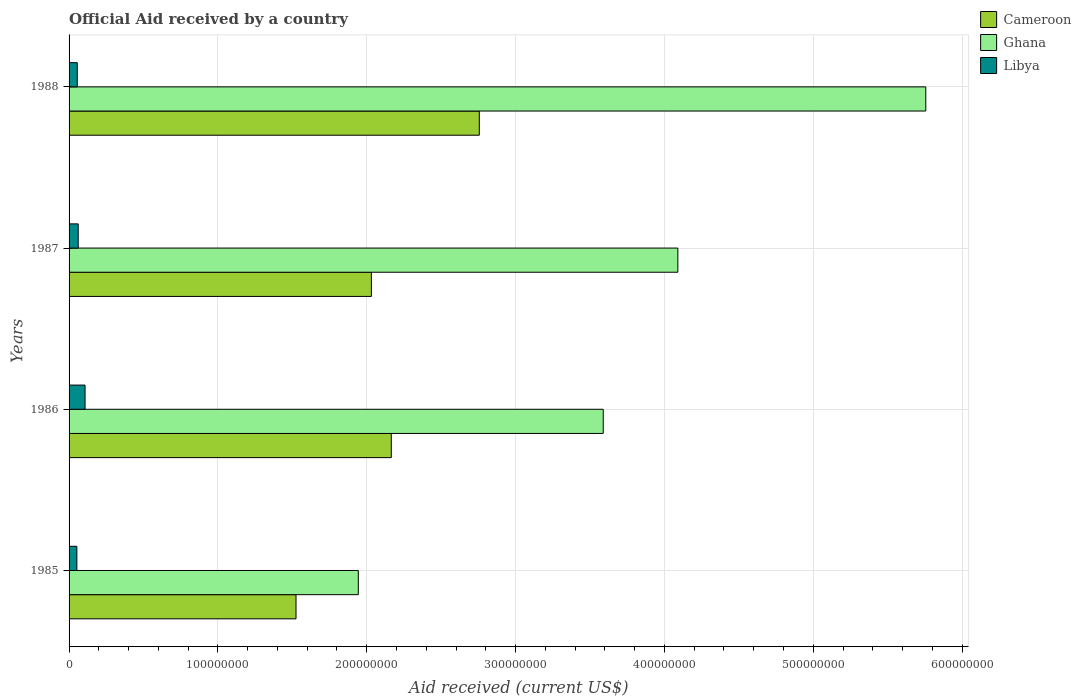Are the number of bars per tick equal to the number of legend labels?
Your response must be concise. Yes. How many bars are there on the 4th tick from the top?
Keep it short and to the point. 3. How many bars are there on the 4th tick from the bottom?
Offer a terse response. 3. What is the label of the 1st group of bars from the top?
Your answer should be very brief. 1988. In how many cases, is the number of bars for a given year not equal to the number of legend labels?
Make the answer very short. 0. What is the net official aid received in Ghana in 1987?
Your response must be concise. 4.09e+08. Across all years, what is the maximum net official aid received in Libya?
Offer a terse response. 1.07e+07. Across all years, what is the minimum net official aid received in Ghana?
Make the answer very short. 1.94e+08. In which year was the net official aid received in Cameroon minimum?
Provide a short and direct response. 1985. What is the total net official aid received in Cameroon in the graph?
Provide a short and direct response. 8.48e+08. What is the difference between the net official aid received in Cameroon in 1985 and that in 1986?
Your answer should be compact. -6.40e+07. What is the difference between the net official aid received in Cameroon in 1985 and the net official aid received in Libya in 1986?
Make the answer very short. 1.42e+08. What is the average net official aid received in Libya per year?
Make the answer very short. 6.90e+06. In the year 1985, what is the difference between the net official aid received in Cameroon and net official aid received in Libya?
Your answer should be compact. 1.47e+08. What is the ratio of the net official aid received in Cameroon in 1985 to that in 1986?
Your answer should be compact. 0.7. Is the net official aid received in Ghana in 1985 less than that in 1986?
Your response must be concise. Yes. What is the difference between the highest and the second highest net official aid received in Libya?
Your answer should be very brief. 4.61e+06. What is the difference between the highest and the lowest net official aid received in Libya?
Ensure brevity in your answer.  5.51e+06. In how many years, is the net official aid received in Cameroon greater than the average net official aid received in Cameroon taken over all years?
Provide a succinct answer. 2. Is the sum of the net official aid received in Cameroon in 1986 and 1988 greater than the maximum net official aid received in Ghana across all years?
Make the answer very short. No. What does the 1st bar from the top in 1987 represents?
Offer a very short reply. Libya. What does the 2nd bar from the bottom in 1987 represents?
Keep it short and to the point. Ghana. How many bars are there?
Give a very brief answer. 12. Are all the bars in the graph horizontal?
Make the answer very short. Yes. What is the difference between two consecutive major ticks on the X-axis?
Provide a short and direct response. 1.00e+08. Are the values on the major ticks of X-axis written in scientific E-notation?
Your response must be concise. No. Does the graph contain any zero values?
Offer a terse response. No. How many legend labels are there?
Keep it short and to the point. 3. What is the title of the graph?
Offer a terse response. Official Aid received by a country. What is the label or title of the X-axis?
Ensure brevity in your answer.  Aid received (current US$). What is the Aid received (current US$) in Cameroon in 1985?
Make the answer very short. 1.52e+08. What is the Aid received (current US$) of Ghana in 1985?
Make the answer very short. 1.94e+08. What is the Aid received (current US$) of Libya in 1985?
Provide a succinct answer. 5.23e+06. What is the Aid received (current US$) in Cameroon in 1986?
Make the answer very short. 2.16e+08. What is the Aid received (current US$) of Ghana in 1986?
Give a very brief answer. 3.59e+08. What is the Aid received (current US$) of Libya in 1986?
Your answer should be very brief. 1.07e+07. What is the Aid received (current US$) of Cameroon in 1987?
Provide a succinct answer. 2.03e+08. What is the Aid received (current US$) of Ghana in 1987?
Your answer should be very brief. 4.09e+08. What is the Aid received (current US$) of Libya in 1987?
Your answer should be compact. 6.13e+06. What is the Aid received (current US$) in Cameroon in 1988?
Provide a short and direct response. 2.76e+08. What is the Aid received (current US$) of Ghana in 1988?
Your answer should be compact. 5.76e+08. What is the Aid received (current US$) in Libya in 1988?
Your answer should be very brief. 5.50e+06. Across all years, what is the maximum Aid received (current US$) in Cameroon?
Your answer should be compact. 2.76e+08. Across all years, what is the maximum Aid received (current US$) in Ghana?
Your answer should be very brief. 5.76e+08. Across all years, what is the maximum Aid received (current US$) in Libya?
Give a very brief answer. 1.07e+07. Across all years, what is the minimum Aid received (current US$) in Cameroon?
Keep it short and to the point. 1.52e+08. Across all years, what is the minimum Aid received (current US$) of Ghana?
Give a very brief answer. 1.94e+08. Across all years, what is the minimum Aid received (current US$) in Libya?
Offer a very short reply. 5.23e+06. What is the total Aid received (current US$) of Cameroon in the graph?
Your response must be concise. 8.48e+08. What is the total Aid received (current US$) of Ghana in the graph?
Keep it short and to the point. 1.54e+09. What is the total Aid received (current US$) of Libya in the graph?
Provide a succinct answer. 2.76e+07. What is the difference between the Aid received (current US$) in Cameroon in 1985 and that in 1986?
Make the answer very short. -6.40e+07. What is the difference between the Aid received (current US$) of Ghana in 1985 and that in 1986?
Keep it short and to the point. -1.65e+08. What is the difference between the Aid received (current US$) of Libya in 1985 and that in 1986?
Offer a very short reply. -5.51e+06. What is the difference between the Aid received (current US$) in Cameroon in 1985 and that in 1987?
Your answer should be very brief. -5.06e+07. What is the difference between the Aid received (current US$) of Ghana in 1985 and that in 1987?
Offer a very short reply. -2.15e+08. What is the difference between the Aid received (current US$) in Libya in 1985 and that in 1987?
Make the answer very short. -9.00e+05. What is the difference between the Aid received (current US$) of Cameroon in 1985 and that in 1988?
Give a very brief answer. -1.23e+08. What is the difference between the Aid received (current US$) in Ghana in 1985 and that in 1988?
Offer a terse response. -3.81e+08. What is the difference between the Aid received (current US$) of Cameroon in 1986 and that in 1987?
Offer a terse response. 1.34e+07. What is the difference between the Aid received (current US$) in Ghana in 1986 and that in 1987?
Your response must be concise. -5.01e+07. What is the difference between the Aid received (current US$) in Libya in 1986 and that in 1987?
Your answer should be very brief. 4.61e+06. What is the difference between the Aid received (current US$) in Cameroon in 1986 and that in 1988?
Your answer should be compact. -5.91e+07. What is the difference between the Aid received (current US$) in Ghana in 1986 and that in 1988?
Offer a terse response. -2.17e+08. What is the difference between the Aid received (current US$) of Libya in 1986 and that in 1988?
Your answer should be compact. 5.24e+06. What is the difference between the Aid received (current US$) in Cameroon in 1987 and that in 1988?
Your response must be concise. -7.25e+07. What is the difference between the Aid received (current US$) in Ghana in 1987 and that in 1988?
Keep it short and to the point. -1.67e+08. What is the difference between the Aid received (current US$) of Libya in 1987 and that in 1988?
Offer a terse response. 6.30e+05. What is the difference between the Aid received (current US$) of Cameroon in 1985 and the Aid received (current US$) of Ghana in 1986?
Offer a terse response. -2.06e+08. What is the difference between the Aid received (current US$) in Cameroon in 1985 and the Aid received (current US$) in Libya in 1986?
Offer a terse response. 1.42e+08. What is the difference between the Aid received (current US$) of Ghana in 1985 and the Aid received (current US$) of Libya in 1986?
Provide a short and direct response. 1.84e+08. What is the difference between the Aid received (current US$) of Cameroon in 1985 and the Aid received (current US$) of Ghana in 1987?
Your response must be concise. -2.57e+08. What is the difference between the Aid received (current US$) in Cameroon in 1985 and the Aid received (current US$) in Libya in 1987?
Offer a terse response. 1.46e+08. What is the difference between the Aid received (current US$) in Ghana in 1985 and the Aid received (current US$) in Libya in 1987?
Your answer should be very brief. 1.88e+08. What is the difference between the Aid received (current US$) in Cameroon in 1985 and the Aid received (current US$) in Ghana in 1988?
Offer a very short reply. -4.23e+08. What is the difference between the Aid received (current US$) of Cameroon in 1985 and the Aid received (current US$) of Libya in 1988?
Offer a very short reply. 1.47e+08. What is the difference between the Aid received (current US$) in Ghana in 1985 and the Aid received (current US$) in Libya in 1988?
Ensure brevity in your answer.  1.89e+08. What is the difference between the Aid received (current US$) in Cameroon in 1986 and the Aid received (current US$) in Ghana in 1987?
Your answer should be very brief. -1.93e+08. What is the difference between the Aid received (current US$) in Cameroon in 1986 and the Aid received (current US$) in Libya in 1987?
Offer a terse response. 2.10e+08. What is the difference between the Aid received (current US$) of Ghana in 1986 and the Aid received (current US$) of Libya in 1987?
Make the answer very short. 3.53e+08. What is the difference between the Aid received (current US$) in Cameroon in 1986 and the Aid received (current US$) in Ghana in 1988?
Provide a short and direct response. -3.59e+08. What is the difference between the Aid received (current US$) of Cameroon in 1986 and the Aid received (current US$) of Libya in 1988?
Your response must be concise. 2.11e+08. What is the difference between the Aid received (current US$) of Ghana in 1986 and the Aid received (current US$) of Libya in 1988?
Your response must be concise. 3.53e+08. What is the difference between the Aid received (current US$) of Cameroon in 1987 and the Aid received (current US$) of Ghana in 1988?
Offer a terse response. -3.72e+08. What is the difference between the Aid received (current US$) of Cameroon in 1987 and the Aid received (current US$) of Libya in 1988?
Your answer should be very brief. 1.98e+08. What is the difference between the Aid received (current US$) of Ghana in 1987 and the Aid received (current US$) of Libya in 1988?
Keep it short and to the point. 4.04e+08. What is the average Aid received (current US$) of Cameroon per year?
Ensure brevity in your answer.  2.12e+08. What is the average Aid received (current US$) in Ghana per year?
Your response must be concise. 3.84e+08. What is the average Aid received (current US$) in Libya per year?
Provide a short and direct response. 6.90e+06. In the year 1985, what is the difference between the Aid received (current US$) in Cameroon and Aid received (current US$) in Ghana?
Offer a very short reply. -4.18e+07. In the year 1985, what is the difference between the Aid received (current US$) in Cameroon and Aid received (current US$) in Libya?
Your response must be concise. 1.47e+08. In the year 1985, what is the difference between the Aid received (current US$) in Ghana and Aid received (current US$) in Libya?
Offer a terse response. 1.89e+08. In the year 1986, what is the difference between the Aid received (current US$) in Cameroon and Aid received (current US$) in Ghana?
Offer a very short reply. -1.42e+08. In the year 1986, what is the difference between the Aid received (current US$) in Cameroon and Aid received (current US$) in Libya?
Your answer should be very brief. 2.06e+08. In the year 1986, what is the difference between the Aid received (current US$) in Ghana and Aid received (current US$) in Libya?
Provide a succinct answer. 3.48e+08. In the year 1987, what is the difference between the Aid received (current US$) of Cameroon and Aid received (current US$) of Ghana?
Offer a terse response. -2.06e+08. In the year 1987, what is the difference between the Aid received (current US$) in Cameroon and Aid received (current US$) in Libya?
Ensure brevity in your answer.  1.97e+08. In the year 1987, what is the difference between the Aid received (current US$) of Ghana and Aid received (current US$) of Libya?
Offer a very short reply. 4.03e+08. In the year 1988, what is the difference between the Aid received (current US$) of Cameroon and Aid received (current US$) of Ghana?
Provide a short and direct response. -3.00e+08. In the year 1988, what is the difference between the Aid received (current US$) of Cameroon and Aid received (current US$) of Libya?
Make the answer very short. 2.70e+08. In the year 1988, what is the difference between the Aid received (current US$) in Ghana and Aid received (current US$) in Libya?
Your response must be concise. 5.70e+08. What is the ratio of the Aid received (current US$) in Cameroon in 1985 to that in 1986?
Your answer should be compact. 0.7. What is the ratio of the Aid received (current US$) of Ghana in 1985 to that in 1986?
Offer a very short reply. 0.54. What is the ratio of the Aid received (current US$) in Libya in 1985 to that in 1986?
Your response must be concise. 0.49. What is the ratio of the Aid received (current US$) of Cameroon in 1985 to that in 1987?
Make the answer very short. 0.75. What is the ratio of the Aid received (current US$) in Ghana in 1985 to that in 1987?
Your answer should be compact. 0.48. What is the ratio of the Aid received (current US$) in Libya in 1985 to that in 1987?
Provide a succinct answer. 0.85. What is the ratio of the Aid received (current US$) in Cameroon in 1985 to that in 1988?
Offer a terse response. 0.55. What is the ratio of the Aid received (current US$) of Ghana in 1985 to that in 1988?
Your answer should be compact. 0.34. What is the ratio of the Aid received (current US$) of Libya in 1985 to that in 1988?
Provide a short and direct response. 0.95. What is the ratio of the Aid received (current US$) in Cameroon in 1986 to that in 1987?
Make the answer very short. 1.07. What is the ratio of the Aid received (current US$) in Ghana in 1986 to that in 1987?
Offer a very short reply. 0.88. What is the ratio of the Aid received (current US$) in Libya in 1986 to that in 1987?
Your answer should be very brief. 1.75. What is the ratio of the Aid received (current US$) in Cameroon in 1986 to that in 1988?
Your answer should be compact. 0.79. What is the ratio of the Aid received (current US$) of Ghana in 1986 to that in 1988?
Make the answer very short. 0.62. What is the ratio of the Aid received (current US$) in Libya in 1986 to that in 1988?
Offer a very short reply. 1.95. What is the ratio of the Aid received (current US$) of Cameroon in 1987 to that in 1988?
Provide a short and direct response. 0.74. What is the ratio of the Aid received (current US$) of Ghana in 1987 to that in 1988?
Provide a short and direct response. 0.71. What is the ratio of the Aid received (current US$) in Libya in 1987 to that in 1988?
Ensure brevity in your answer.  1.11. What is the difference between the highest and the second highest Aid received (current US$) in Cameroon?
Offer a very short reply. 5.91e+07. What is the difference between the highest and the second highest Aid received (current US$) in Ghana?
Keep it short and to the point. 1.67e+08. What is the difference between the highest and the second highest Aid received (current US$) of Libya?
Keep it short and to the point. 4.61e+06. What is the difference between the highest and the lowest Aid received (current US$) in Cameroon?
Your response must be concise. 1.23e+08. What is the difference between the highest and the lowest Aid received (current US$) in Ghana?
Give a very brief answer. 3.81e+08. What is the difference between the highest and the lowest Aid received (current US$) of Libya?
Give a very brief answer. 5.51e+06. 